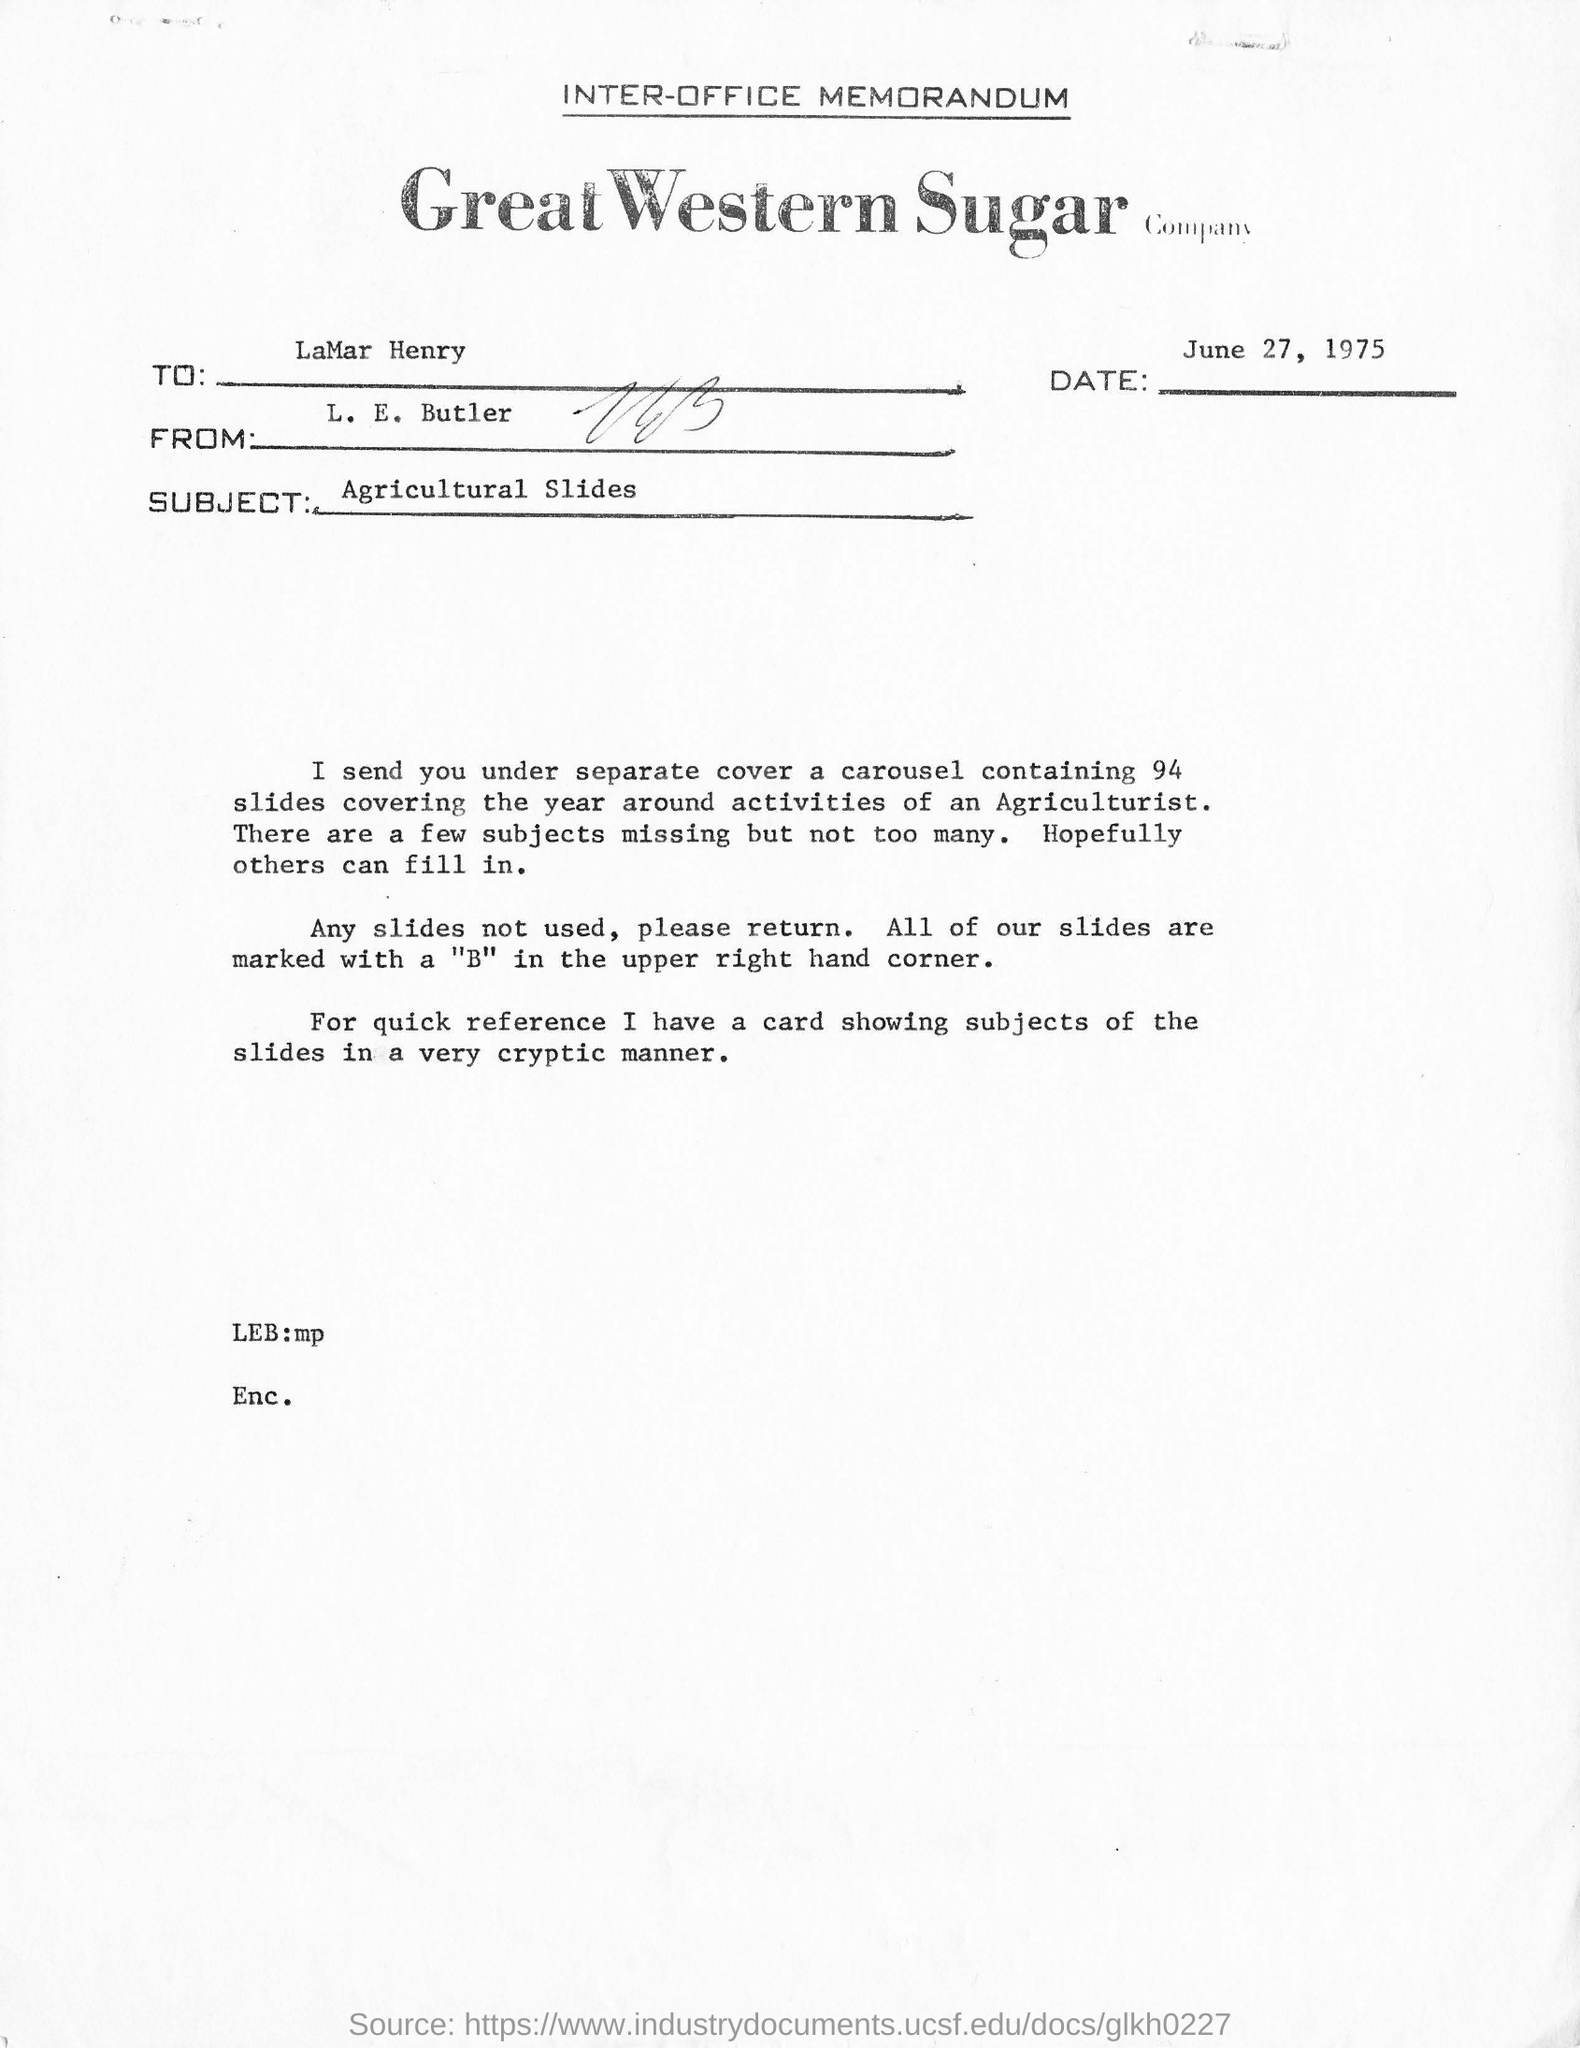Point out several critical features in this image. The subject is "Agricultural Slides. The date mentioned in the document is June 27, 1975. The Great Western Sugar Company is a company that is inquiring about the name of another company. The year-round activities of an Agriculturist are expected to be covered by 94 slides. The top of the document reads 'INTER-OFFICE MEMORANDUM.' 